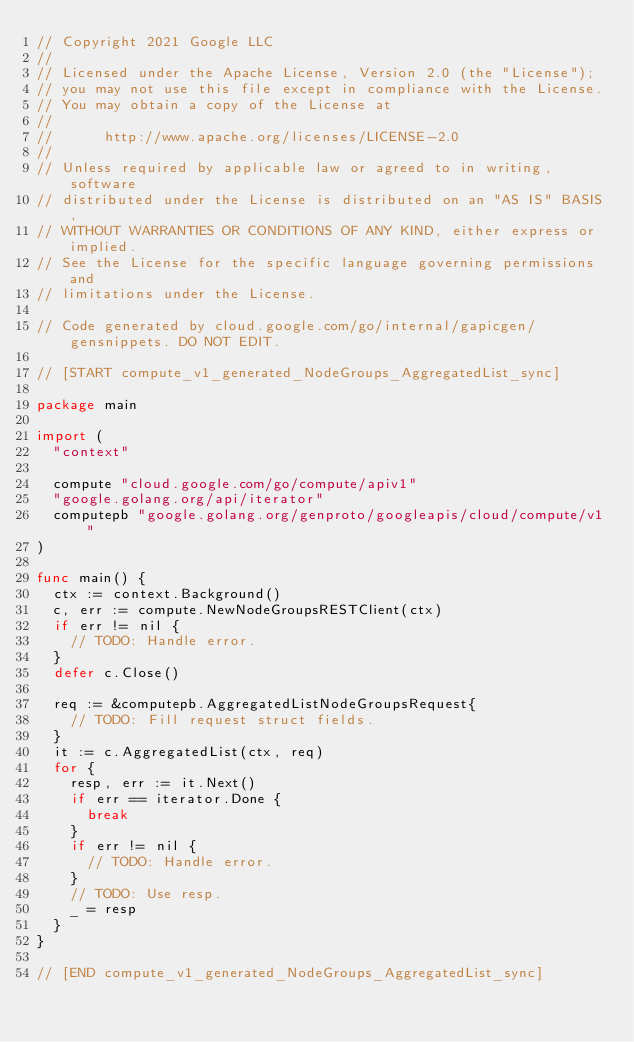<code> <loc_0><loc_0><loc_500><loc_500><_Go_>// Copyright 2021 Google LLC
//
// Licensed under the Apache License, Version 2.0 (the "License");
// you may not use this file except in compliance with the License.
// You may obtain a copy of the License at
//
//      http://www.apache.org/licenses/LICENSE-2.0
//
// Unless required by applicable law or agreed to in writing, software
// distributed under the License is distributed on an "AS IS" BASIS,
// WITHOUT WARRANTIES OR CONDITIONS OF ANY KIND, either express or implied.
// See the License for the specific language governing permissions and
// limitations under the License.

// Code generated by cloud.google.com/go/internal/gapicgen/gensnippets. DO NOT EDIT.

// [START compute_v1_generated_NodeGroups_AggregatedList_sync]

package main

import (
	"context"

	compute "cloud.google.com/go/compute/apiv1"
	"google.golang.org/api/iterator"
	computepb "google.golang.org/genproto/googleapis/cloud/compute/v1"
)

func main() {
	ctx := context.Background()
	c, err := compute.NewNodeGroupsRESTClient(ctx)
	if err != nil {
		// TODO: Handle error.
	}
	defer c.Close()

	req := &computepb.AggregatedListNodeGroupsRequest{
		// TODO: Fill request struct fields.
	}
	it := c.AggregatedList(ctx, req)
	for {
		resp, err := it.Next()
		if err == iterator.Done {
			break
		}
		if err != nil {
			// TODO: Handle error.
		}
		// TODO: Use resp.
		_ = resp
	}
}

// [END compute_v1_generated_NodeGroups_AggregatedList_sync]
</code> 